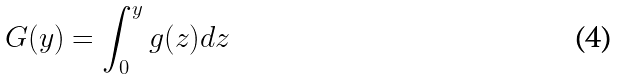<formula> <loc_0><loc_0><loc_500><loc_500>G ( y ) = \int _ { 0 } ^ { y } g ( z ) d z</formula> 